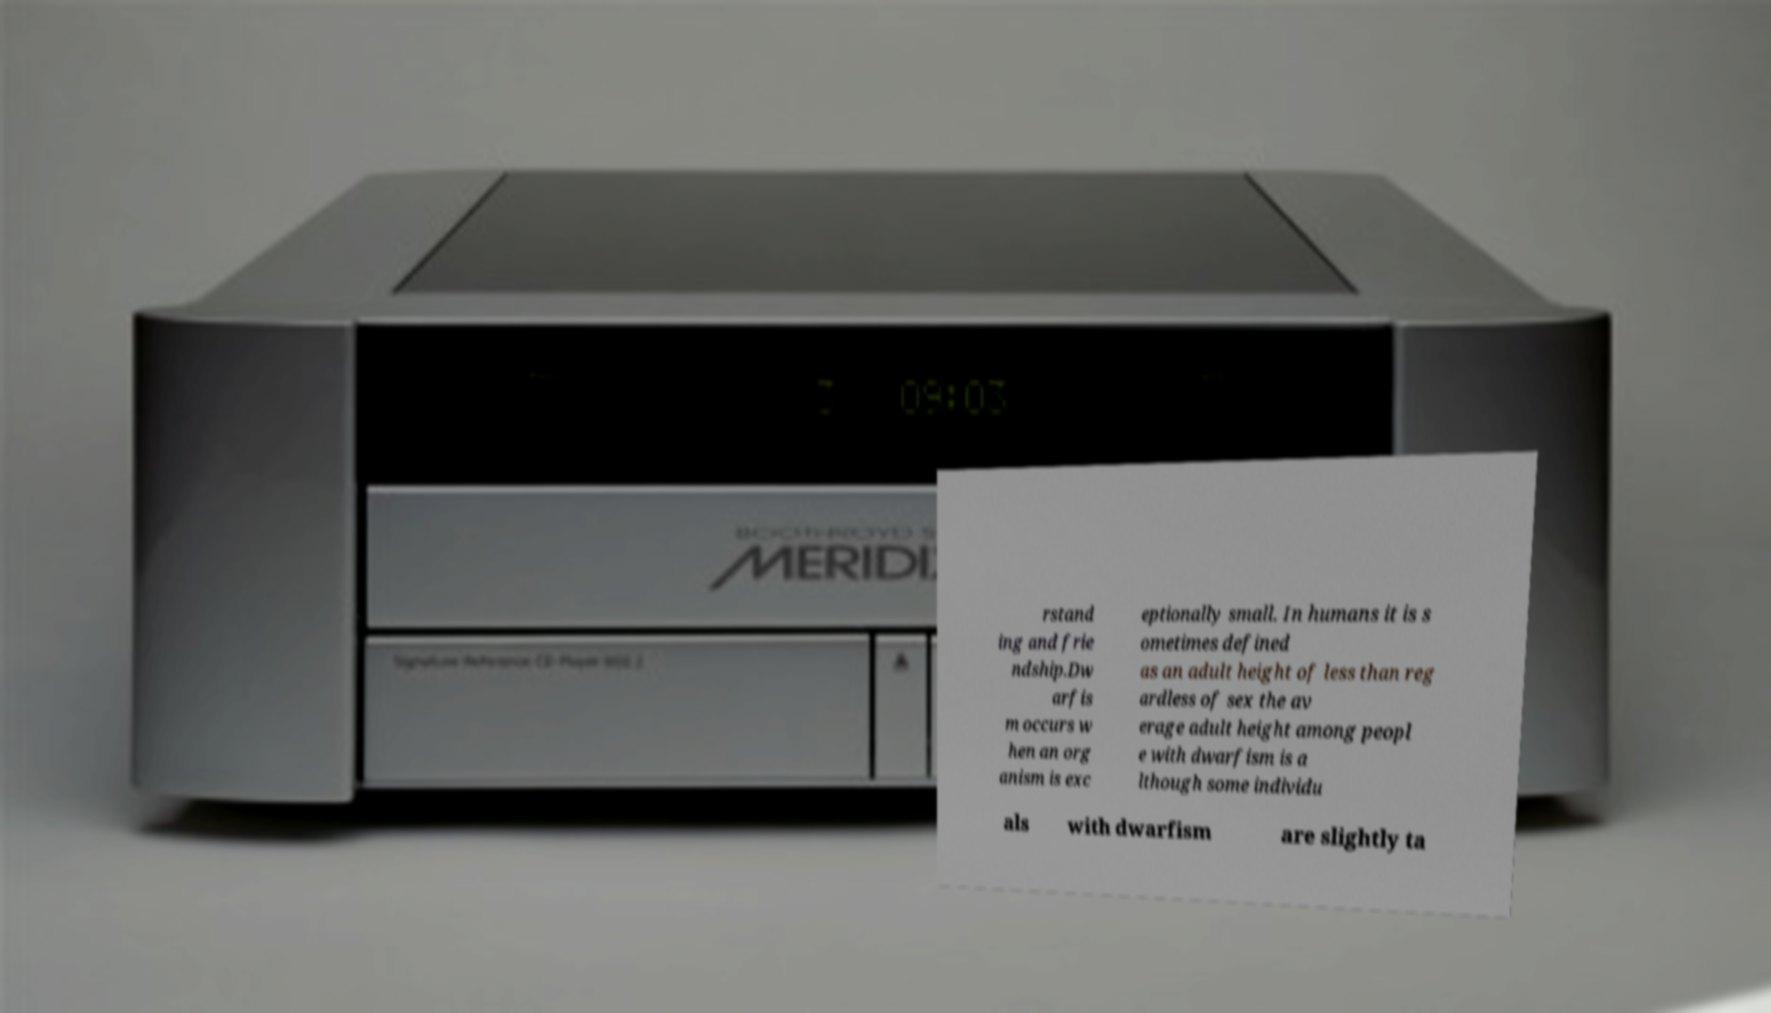Could you assist in decoding the text presented in this image and type it out clearly? rstand ing and frie ndship.Dw arfis m occurs w hen an org anism is exc eptionally small. In humans it is s ometimes defined as an adult height of less than reg ardless of sex the av erage adult height among peopl e with dwarfism is a lthough some individu als with dwarfism are slightly ta 